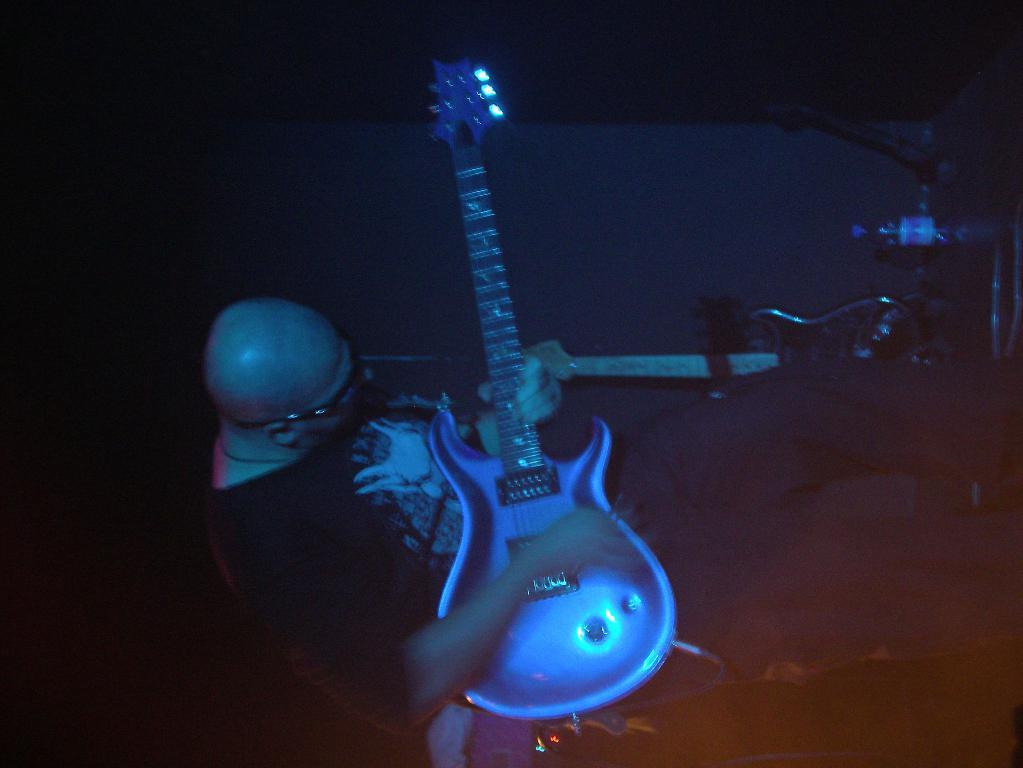What is the person in the image doing? The person is holding a guitar in his hand. Are there any other musical instruments visible in the image? Yes, there is another guitar visible in the image. What can be seen in the background of the image? There are a few objects in the background, and the background has a dark view. How many babies are visible in the image? There are no babies present in the image. What type of needle is being used by the person in the image? There is no needle visible in the image; the person is holding a guitar. 